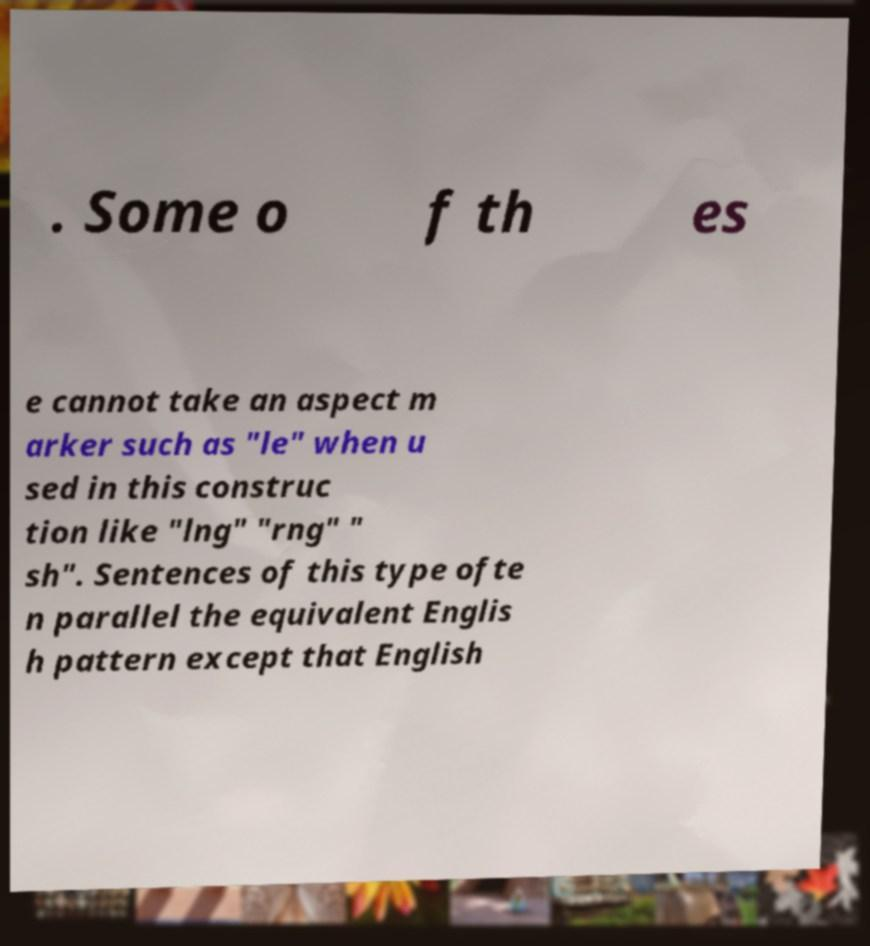Could you extract and type out the text from this image? . Some o f th es e cannot take an aspect m arker such as "le" when u sed in this construc tion like "lng" "rng" " sh". Sentences of this type ofte n parallel the equivalent Englis h pattern except that English 